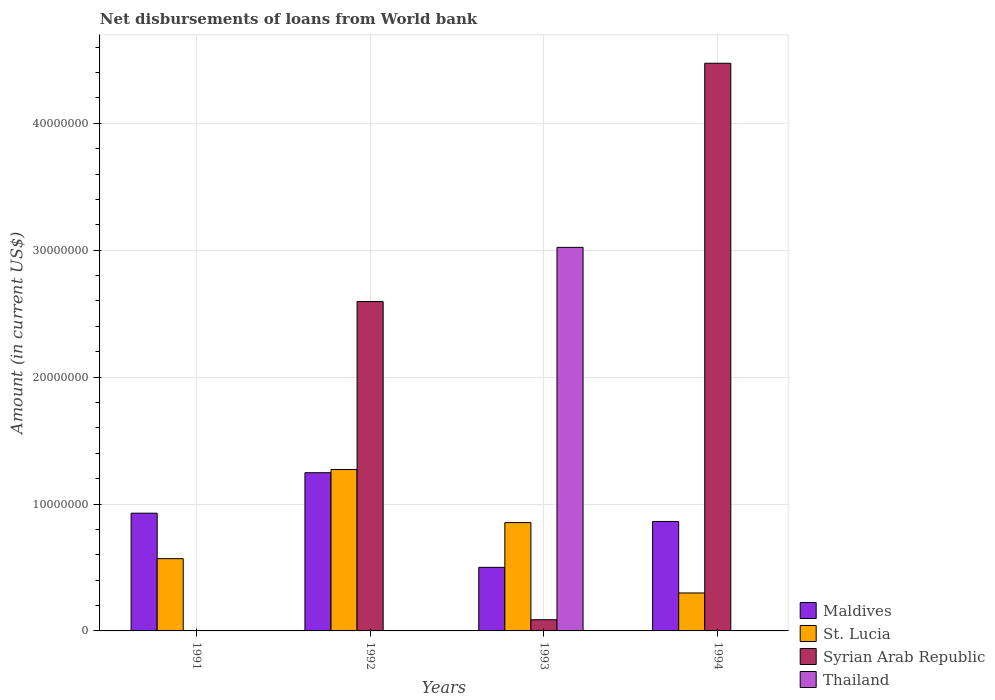How many groups of bars are there?
Your response must be concise. 4. How many bars are there on the 3rd tick from the right?
Keep it short and to the point. 3. What is the label of the 1st group of bars from the left?
Ensure brevity in your answer.  1991. In how many cases, is the number of bars for a given year not equal to the number of legend labels?
Offer a very short reply. 3. What is the amount of loan disbursed from World Bank in Syrian Arab Republic in 1993?
Offer a terse response. 8.82e+05. Across all years, what is the maximum amount of loan disbursed from World Bank in Maldives?
Offer a terse response. 1.25e+07. Across all years, what is the minimum amount of loan disbursed from World Bank in Thailand?
Your response must be concise. 0. What is the total amount of loan disbursed from World Bank in Syrian Arab Republic in the graph?
Offer a terse response. 7.16e+07. What is the difference between the amount of loan disbursed from World Bank in Maldives in 1993 and that in 1994?
Provide a succinct answer. -3.62e+06. What is the difference between the amount of loan disbursed from World Bank in Syrian Arab Republic in 1993 and the amount of loan disbursed from World Bank in Thailand in 1991?
Your answer should be very brief. 8.82e+05. What is the average amount of loan disbursed from World Bank in St. Lucia per year?
Make the answer very short. 7.49e+06. In the year 1993, what is the difference between the amount of loan disbursed from World Bank in Syrian Arab Republic and amount of loan disbursed from World Bank in St. Lucia?
Keep it short and to the point. -7.65e+06. What is the ratio of the amount of loan disbursed from World Bank in St. Lucia in 1992 to that in 1993?
Offer a terse response. 1.49. Is the amount of loan disbursed from World Bank in Maldives in 1991 less than that in 1993?
Offer a very short reply. No. What is the difference between the highest and the second highest amount of loan disbursed from World Bank in Maldives?
Offer a terse response. 3.19e+06. What is the difference between the highest and the lowest amount of loan disbursed from World Bank in Syrian Arab Republic?
Your answer should be very brief. 4.47e+07. Is it the case that in every year, the sum of the amount of loan disbursed from World Bank in St. Lucia and amount of loan disbursed from World Bank in Syrian Arab Republic is greater than the sum of amount of loan disbursed from World Bank in Maldives and amount of loan disbursed from World Bank in Thailand?
Make the answer very short. No. How many bars are there?
Give a very brief answer. 12. Are all the bars in the graph horizontal?
Provide a succinct answer. No. What is the difference between two consecutive major ticks on the Y-axis?
Give a very brief answer. 1.00e+07. Where does the legend appear in the graph?
Your response must be concise. Bottom right. How many legend labels are there?
Give a very brief answer. 4. How are the legend labels stacked?
Make the answer very short. Vertical. What is the title of the graph?
Give a very brief answer. Net disbursements of loans from World bank. What is the Amount (in current US$) of Maldives in 1991?
Make the answer very short. 9.28e+06. What is the Amount (in current US$) of St. Lucia in 1991?
Your response must be concise. 5.70e+06. What is the Amount (in current US$) in Maldives in 1992?
Provide a short and direct response. 1.25e+07. What is the Amount (in current US$) in St. Lucia in 1992?
Provide a short and direct response. 1.27e+07. What is the Amount (in current US$) in Syrian Arab Republic in 1992?
Provide a succinct answer. 2.60e+07. What is the Amount (in current US$) in Thailand in 1992?
Provide a short and direct response. 0. What is the Amount (in current US$) of Maldives in 1993?
Provide a succinct answer. 5.01e+06. What is the Amount (in current US$) in St. Lucia in 1993?
Your answer should be very brief. 8.54e+06. What is the Amount (in current US$) of Syrian Arab Republic in 1993?
Your answer should be compact. 8.82e+05. What is the Amount (in current US$) of Thailand in 1993?
Give a very brief answer. 3.02e+07. What is the Amount (in current US$) of Maldives in 1994?
Ensure brevity in your answer.  8.63e+06. What is the Amount (in current US$) of St. Lucia in 1994?
Make the answer very short. 2.99e+06. What is the Amount (in current US$) of Syrian Arab Republic in 1994?
Offer a very short reply. 4.47e+07. Across all years, what is the maximum Amount (in current US$) in Maldives?
Keep it short and to the point. 1.25e+07. Across all years, what is the maximum Amount (in current US$) in St. Lucia?
Your answer should be very brief. 1.27e+07. Across all years, what is the maximum Amount (in current US$) in Syrian Arab Republic?
Make the answer very short. 4.47e+07. Across all years, what is the maximum Amount (in current US$) of Thailand?
Ensure brevity in your answer.  3.02e+07. Across all years, what is the minimum Amount (in current US$) of Maldives?
Offer a terse response. 5.01e+06. Across all years, what is the minimum Amount (in current US$) in St. Lucia?
Make the answer very short. 2.99e+06. Across all years, what is the minimum Amount (in current US$) of Thailand?
Your response must be concise. 0. What is the total Amount (in current US$) in Maldives in the graph?
Give a very brief answer. 3.54e+07. What is the total Amount (in current US$) of St. Lucia in the graph?
Offer a terse response. 2.99e+07. What is the total Amount (in current US$) of Syrian Arab Republic in the graph?
Your answer should be very brief. 7.16e+07. What is the total Amount (in current US$) of Thailand in the graph?
Provide a succinct answer. 3.02e+07. What is the difference between the Amount (in current US$) in Maldives in 1991 and that in 1992?
Your answer should be compact. -3.19e+06. What is the difference between the Amount (in current US$) of St. Lucia in 1991 and that in 1992?
Provide a succinct answer. -7.03e+06. What is the difference between the Amount (in current US$) of Maldives in 1991 and that in 1993?
Your answer should be very brief. 4.27e+06. What is the difference between the Amount (in current US$) in St. Lucia in 1991 and that in 1993?
Provide a short and direct response. -2.84e+06. What is the difference between the Amount (in current US$) in Maldives in 1991 and that in 1994?
Offer a very short reply. 6.51e+05. What is the difference between the Amount (in current US$) of St. Lucia in 1991 and that in 1994?
Offer a very short reply. 2.70e+06. What is the difference between the Amount (in current US$) of Maldives in 1992 and that in 1993?
Keep it short and to the point. 7.46e+06. What is the difference between the Amount (in current US$) in St. Lucia in 1992 and that in 1993?
Make the answer very short. 4.19e+06. What is the difference between the Amount (in current US$) in Syrian Arab Republic in 1992 and that in 1993?
Ensure brevity in your answer.  2.51e+07. What is the difference between the Amount (in current US$) in Maldives in 1992 and that in 1994?
Your response must be concise. 3.84e+06. What is the difference between the Amount (in current US$) in St. Lucia in 1992 and that in 1994?
Provide a short and direct response. 9.73e+06. What is the difference between the Amount (in current US$) in Syrian Arab Republic in 1992 and that in 1994?
Give a very brief answer. -1.88e+07. What is the difference between the Amount (in current US$) of Maldives in 1993 and that in 1994?
Make the answer very short. -3.62e+06. What is the difference between the Amount (in current US$) of St. Lucia in 1993 and that in 1994?
Give a very brief answer. 5.54e+06. What is the difference between the Amount (in current US$) of Syrian Arab Republic in 1993 and that in 1994?
Your answer should be very brief. -4.39e+07. What is the difference between the Amount (in current US$) of Maldives in 1991 and the Amount (in current US$) of St. Lucia in 1992?
Your answer should be very brief. -3.45e+06. What is the difference between the Amount (in current US$) in Maldives in 1991 and the Amount (in current US$) in Syrian Arab Republic in 1992?
Offer a terse response. -1.67e+07. What is the difference between the Amount (in current US$) of St. Lucia in 1991 and the Amount (in current US$) of Syrian Arab Republic in 1992?
Ensure brevity in your answer.  -2.03e+07. What is the difference between the Amount (in current US$) of Maldives in 1991 and the Amount (in current US$) of St. Lucia in 1993?
Ensure brevity in your answer.  7.41e+05. What is the difference between the Amount (in current US$) in Maldives in 1991 and the Amount (in current US$) in Syrian Arab Republic in 1993?
Provide a succinct answer. 8.40e+06. What is the difference between the Amount (in current US$) of Maldives in 1991 and the Amount (in current US$) of Thailand in 1993?
Provide a succinct answer. -2.09e+07. What is the difference between the Amount (in current US$) in St. Lucia in 1991 and the Amount (in current US$) in Syrian Arab Republic in 1993?
Keep it short and to the point. 4.81e+06. What is the difference between the Amount (in current US$) in St. Lucia in 1991 and the Amount (in current US$) in Thailand in 1993?
Ensure brevity in your answer.  -2.45e+07. What is the difference between the Amount (in current US$) of Maldives in 1991 and the Amount (in current US$) of St. Lucia in 1994?
Provide a succinct answer. 6.28e+06. What is the difference between the Amount (in current US$) in Maldives in 1991 and the Amount (in current US$) in Syrian Arab Republic in 1994?
Provide a short and direct response. -3.55e+07. What is the difference between the Amount (in current US$) in St. Lucia in 1991 and the Amount (in current US$) in Syrian Arab Republic in 1994?
Ensure brevity in your answer.  -3.90e+07. What is the difference between the Amount (in current US$) in Maldives in 1992 and the Amount (in current US$) in St. Lucia in 1993?
Your answer should be compact. 3.93e+06. What is the difference between the Amount (in current US$) in Maldives in 1992 and the Amount (in current US$) in Syrian Arab Republic in 1993?
Keep it short and to the point. 1.16e+07. What is the difference between the Amount (in current US$) in Maldives in 1992 and the Amount (in current US$) in Thailand in 1993?
Make the answer very short. -1.78e+07. What is the difference between the Amount (in current US$) of St. Lucia in 1992 and the Amount (in current US$) of Syrian Arab Republic in 1993?
Keep it short and to the point. 1.18e+07. What is the difference between the Amount (in current US$) of St. Lucia in 1992 and the Amount (in current US$) of Thailand in 1993?
Provide a succinct answer. -1.75e+07. What is the difference between the Amount (in current US$) in Syrian Arab Republic in 1992 and the Amount (in current US$) in Thailand in 1993?
Ensure brevity in your answer.  -4.27e+06. What is the difference between the Amount (in current US$) of Maldives in 1992 and the Amount (in current US$) of St. Lucia in 1994?
Provide a succinct answer. 9.48e+06. What is the difference between the Amount (in current US$) of Maldives in 1992 and the Amount (in current US$) of Syrian Arab Republic in 1994?
Give a very brief answer. -3.23e+07. What is the difference between the Amount (in current US$) in St. Lucia in 1992 and the Amount (in current US$) in Syrian Arab Republic in 1994?
Provide a short and direct response. -3.20e+07. What is the difference between the Amount (in current US$) of Maldives in 1993 and the Amount (in current US$) of St. Lucia in 1994?
Ensure brevity in your answer.  2.02e+06. What is the difference between the Amount (in current US$) of Maldives in 1993 and the Amount (in current US$) of Syrian Arab Republic in 1994?
Make the answer very short. -3.97e+07. What is the difference between the Amount (in current US$) in St. Lucia in 1993 and the Amount (in current US$) in Syrian Arab Republic in 1994?
Your response must be concise. -3.62e+07. What is the average Amount (in current US$) in Maldives per year?
Provide a short and direct response. 8.84e+06. What is the average Amount (in current US$) in St. Lucia per year?
Give a very brief answer. 7.49e+06. What is the average Amount (in current US$) of Syrian Arab Republic per year?
Offer a very short reply. 1.79e+07. What is the average Amount (in current US$) in Thailand per year?
Make the answer very short. 7.56e+06. In the year 1991, what is the difference between the Amount (in current US$) of Maldives and Amount (in current US$) of St. Lucia?
Your answer should be compact. 3.58e+06. In the year 1992, what is the difference between the Amount (in current US$) of Maldives and Amount (in current US$) of St. Lucia?
Offer a very short reply. -2.56e+05. In the year 1992, what is the difference between the Amount (in current US$) in Maldives and Amount (in current US$) in Syrian Arab Republic?
Provide a short and direct response. -1.35e+07. In the year 1992, what is the difference between the Amount (in current US$) of St. Lucia and Amount (in current US$) of Syrian Arab Republic?
Offer a very short reply. -1.32e+07. In the year 1993, what is the difference between the Amount (in current US$) of Maldives and Amount (in current US$) of St. Lucia?
Your answer should be very brief. -3.53e+06. In the year 1993, what is the difference between the Amount (in current US$) in Maldives and Amount (in current US$) in Syrian Arab Republic?
Your response must be concise. 4.13e+06. In the year 1993, what is the difference between the Amount (in current US$) of Maldives and Amount (in current US$) of Thailand?
Provide a short and direct response. -2.52e+07. In the year 1993, what is the difference between the Amount (in current US$) in St. Lucia and Amount (in current US$) in Syrian Arab Republic?
Keep it short and to the point. 7.65e+06. In the year 1993, what is the difference between the Amount (in current US$) in St. Lucia and Amount (in current US$) in Thailand?
Provide a succinct answer. -2.17e+07. In the year 1993, what is the difference between the Amount (in current US$) of Syrian Arab Republic and Amount (in current US$) of Thailand?
Ensure brevity in your answer.  -2.93e+07. In the year 1994, what is the difference between the Amount (in current US$) of Maldives and Amount (in current US$) of St. Lucia?
Your answer should be compact. 5.63e+06. In the year 1994, what is the difference between the Amount (in current US$) in Maldives and Amount (in current US$) in Syrian Arab Republic?
Make the answer very short. -3.61e+07. In the year 1994, what is the difference between the Amount (in current US$) in St. Lucia and Amount (in current US$) in Syrian Arab Republic?
Your answer should be very brief. -4.17e+07. What is the ratio of the Amount (in current US$) in Maldives in 1991 to that in 1992?
Give a very brief answer. 0.74. What is the ratio of the Amount (in current US$) in St. Lucia in 1991 to that in 1992?
Ensure brevity in your answer.  0.45. What is the ratio of the Amount (in current US$) in Maldives in 1991 to that in 1993?
Offer a very short reply. 1.85. What is the ratio of the Amount (in current US$) of St. Lucia in 1991 to that in 1993?
Give a very brief answer. 0.67. What is the ratio of the Amount (in current US$) of Maldives in 1991 to that in 1994?
Your response must be concise. 1.08. What is the ratio of the Amount (in current US$) of St. Lucia in 1991 to that in 1994?
Your answer should be compact. 1.9. What is the ratio of the Amount (in current US$) of Maldives in 1992 to that in 1993?
Provide a short and direct response. 2.49. What is the ratio of the Amount (in current US$) of St. Lucia in 1992 to that in 1993?
Your answer should be very brief. 1.49. What is the ratio of the Amount (in current US$) of Syrian Arab Republic in 1992 to that in 1993?
Your answer should be very brief. 29.43. What is the ratio of the Amount (in current US$) in Maldives in 1992 to that in 1994?
Keep it short and to the point. 1.45. What is the ratio of the Amount (in current US$) in St. Lucia in 1992 to that in 1994?
Keep it short and to the point. 4.25. What is the ratio of the Amount (in current US$) of Syrian Arab Republic in 1992 to that in 1994?
Your answer should be very brief. 0.58. What is the ratio of the Amount (in current US$) of Maldives in 1993 to that in 1994?
Provide a short and direct response. 0.58. What is the ratio of the Amount (in current US$) of St. Lucia in 1993 to that in 1994?
Ensure brevity in your answer.  2.85. What is the ratio of the Amount (in current US$) of Syrian Arab Republic in 1993 to that in 1994?
Provide a short and direct response. 0.02. What is the difference between the highest and the second highest Amount (in current US$) in Maldives?
Your answer should be very brief. 3.19e+06. What is the difference between the highest and the second highest Amount (in current US$) in St. Lucia?
Ensure brevity in your answer.  4.19e+06. What is the difference between the highest and the second highest Amount (in current US$) in Syrian Arab Republic?
Your answer should be very brief. 1.88e+07. What is the difference between the highest and the lowest Amount (in current US$) in Maldives?
Give a very brief answer. 7.46e+06. What is the difference between the highest and the lowest Amount (in current US$) of St. Lucia?
Keep it short and to the point. 9.73e+06. What is the difference between the highest and the lowest Amount (in current US$) in Syrian Arab Republic?
Keep it short and to the point. 4.47e+07. What is the difference between the highest and the lowest Amount (in current US$) of Thailand?
Make the answer very short. 3.02e+07. 